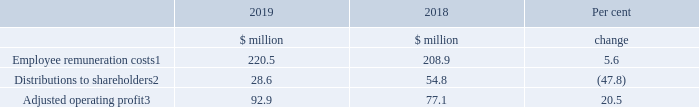Relative importance of the spend on pay
The following table shows the total expenditure on pay for all of the Company’s employees compared to distributions to shareholders by way of dividend. In order to provide context for these figures, adjusted operating profit is also shown.
Notes
1. Remuneration, social security costs, pension and other related costs and expense of share-based payment (see Note 8 to the Consolidated Financial Statements).
2. Dividends declared and paid in the year include a special dividend paid in 2018 (see Note 12 of the Consolidated Financial Statements). Removing the Special Dividend would give a figure for 2018 of $24.9 million with an increase of 14.86 per cent to the 2019 figure of $28.6 million.
3. Before exceptional items, acquisition related costs, acquired tangible asset amortisation and share-based payment amounting to $4.3 million in total (2018 $19.6 million) (see Note 3 of the Consolidated Financial Statements).
What do the employee remuneration costs include? Remuneration, social security costs, pension and other related costs and expense of share-based payment. What do the distributions to shareholders include? Dividends declared and paid in the year include a special dividend paid in 2018. What are the components in the table showing the total expenditure on pay for all of the Company’s employees compared to distributions to shareholders by way of dividend? Employee remuneration costs, distributions to shareholders, adjusted operating profit. In which year was the amount of adjusted operating profit larger? 92.9>77.1
Answer: 2019. What was the change in adjusted operating profit?
Answer scale should be: million. 92.9-77.1
Answer: 15.8. What was the average amount of adjusted operating profit recorded across 2018 and 2019?
Answer scale should be: million. (92.9+77.1)/2
Answer: 85. 